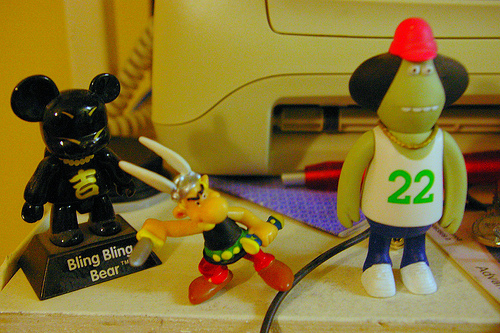<image>
Is there a table behind the toy? No. The table is not behind the toy. From this viewpoint, the table appears to be positioned elsewhere in the scene. 